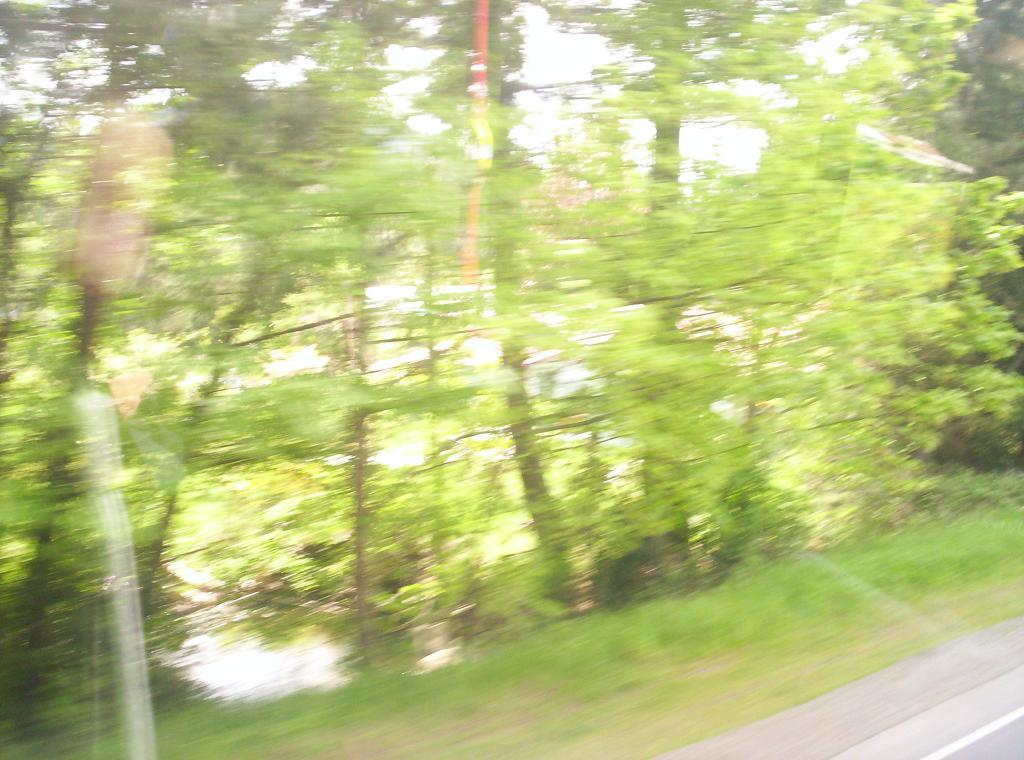What type of vegetation can be seen in the image? There are trees on the grassland in the image. What type of man-made structure is visible in the image? There is a road at the right bottom of the image. What type of yarn is being used to create the trees in the image? There is no yarn present in the image; the trees are real trees. Can you confirm the existence of a sail in the image? There is no sail present in the image. 